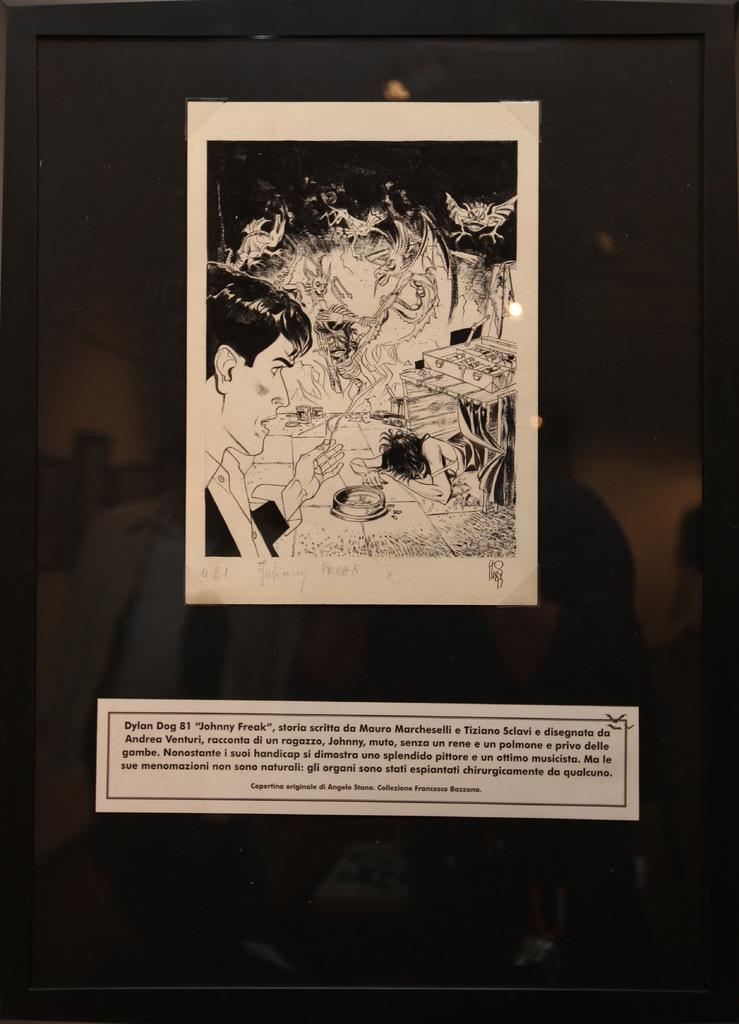<image>
Share a concise interpretation of the image provided. A Dylan Dog 81 black and white adult theme cartoon. 